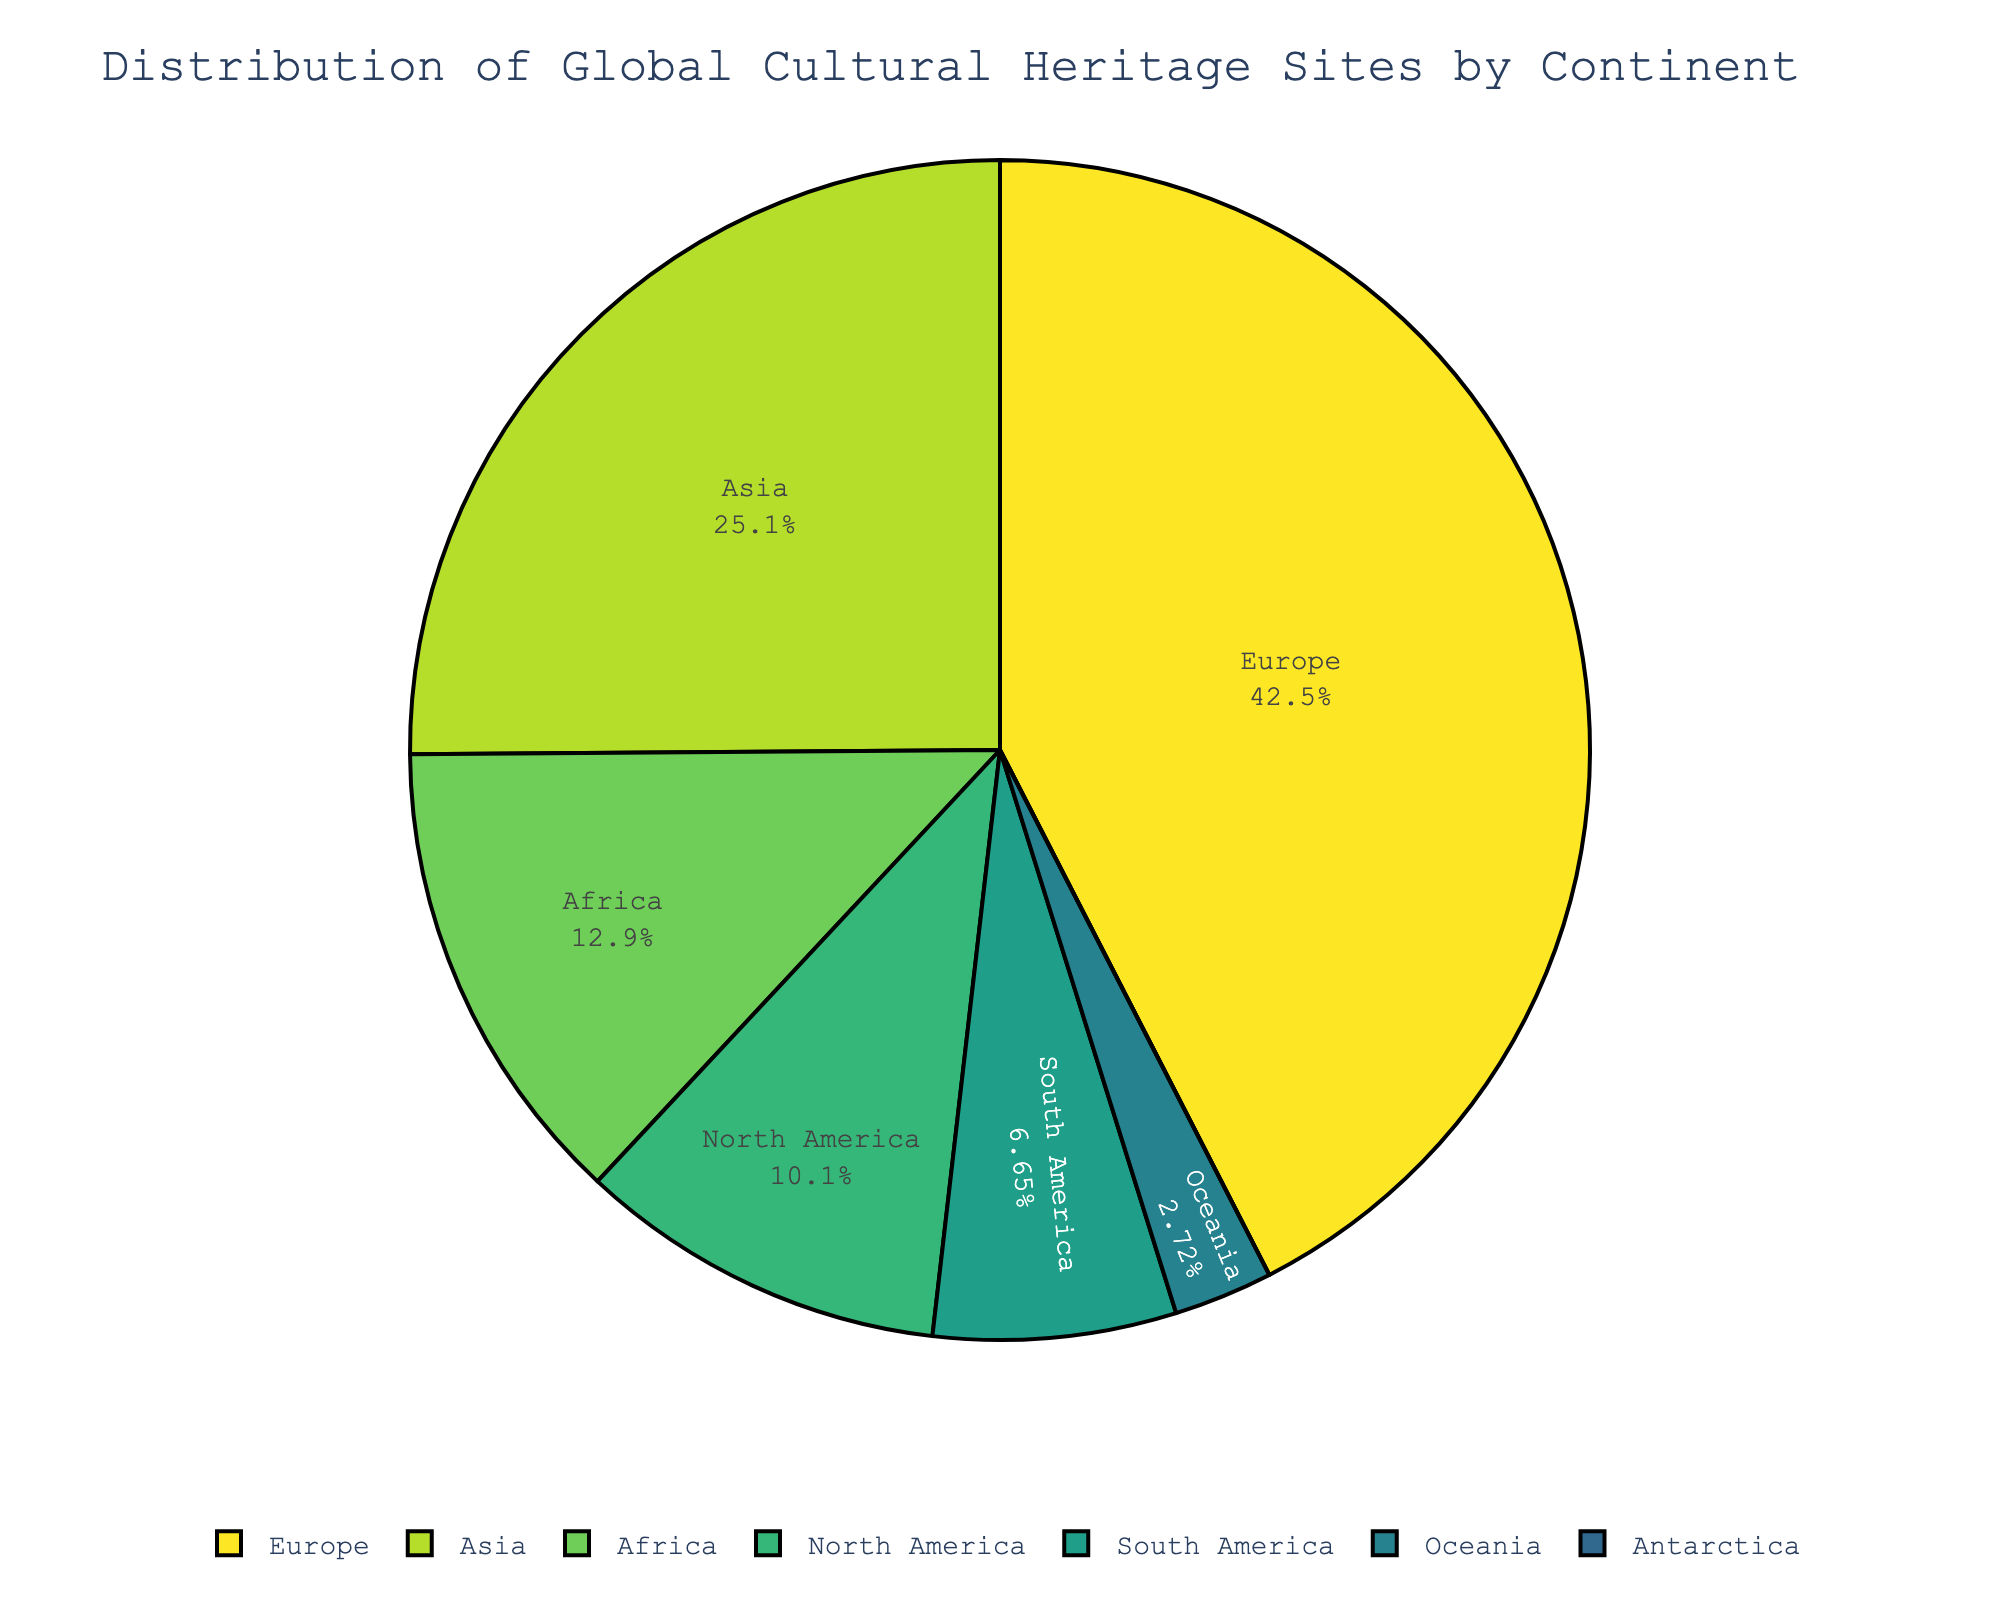Which continent has the highest number of World Heritage Sites? The pie chart shows the distribution of World Heritage Sites among continents. The largest segment corresponds to Europe.
Answer: Europe Which two continents have the smallest number of World Heritage Sites, excluding Antarctica? The two smallest segments in the pie chart, besides the non-existing slice for Antarctica, belong to Oceania and South America.
Answer: Oceania and South America What percentage of the total World Heritage Sites are located in Europe? The pie chart displays the percentage of sites per continent. The segment for Europe shows its percentage explicitly.
Answer: 45% How many more World Heritage Sites does Asia have compared to North America? The pie chart provides the number of sites on each continent. Asia has 268 sites, and North America has 108. The difference is 268 - 108.
Answer: 160 What is the total number of World Heritage Sites in Africa and South America combined? The pie chart shows the number of sites in each continent. Adding Africa's 138 sites and South America's 71 gives the total.
Answer: 209 How does the number of World Heritage Sites in North America compare to that in Oceania? The segments for North America and Oceania show that North America has 108 sites while Oceania has 29. Comparing these numbers, North America has more sites.
Answer: North America has more Which continent has no World Heritage Sites? By observing the pie chart, the segment for Antarctica has a count of 0, indicating no sites.
Answer: Antarctica What is the combined percentage of World Heritage Sites in Asia and Africa? From the pie chart, Asia holds 27% and Africa 14%. Adding these percentages gives the combined total.
Answer: 41% How much lower is the number of World Heritage Sites in South America than in Asia? Subtracting the number of sites in South America (71) from Asia (268) gives the difference.
Answer: 197 In terms of visual attributes, which segment of the chart is the largest? Observing the pie chart, the largest segment represents Europe due to its size.
Answer: Europe 